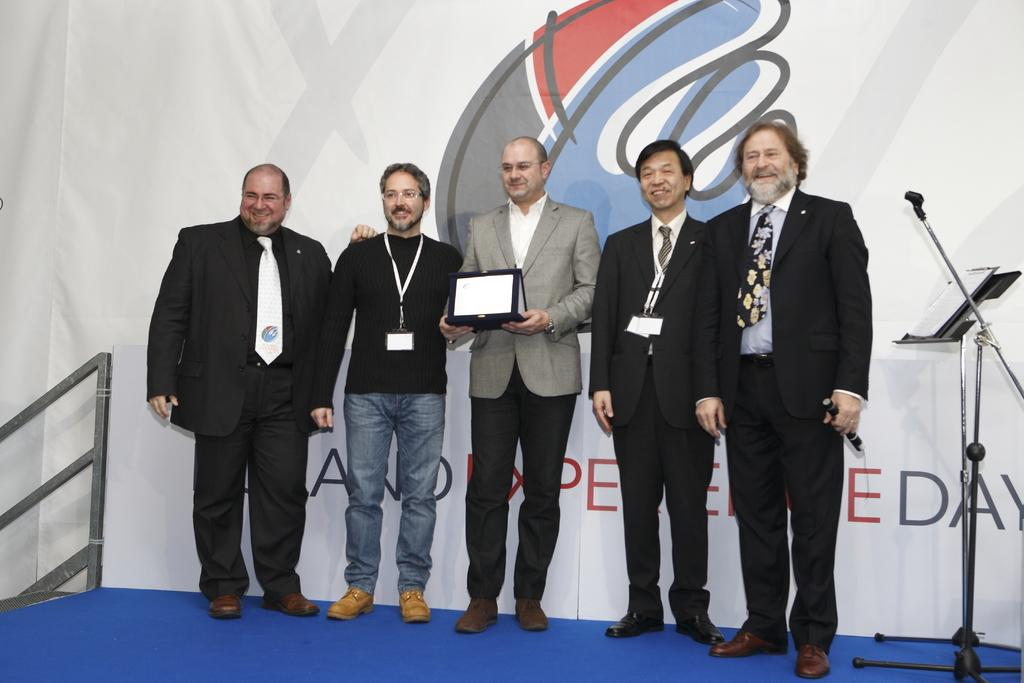How many people are on the stage in the image? There are five people standing on the stage in the image. What is one person holding in the image? A person is holding a laptop in the image. What can be seen near the person holding the laptop? There is a mike stand in the image. What is placed on the mike stand? There is a book on the stand in the image. What is another object visible in the image? There is a board in the image. What type of material is visible in the image? There are iron rods visible in the image. What level of oil is present in the image? There is no mention of oil in the image, so it is not possible to determine the level of oil. What statement is being made by the people on the stage? The image does not provide any information about the statements being made by the people on the stage. 